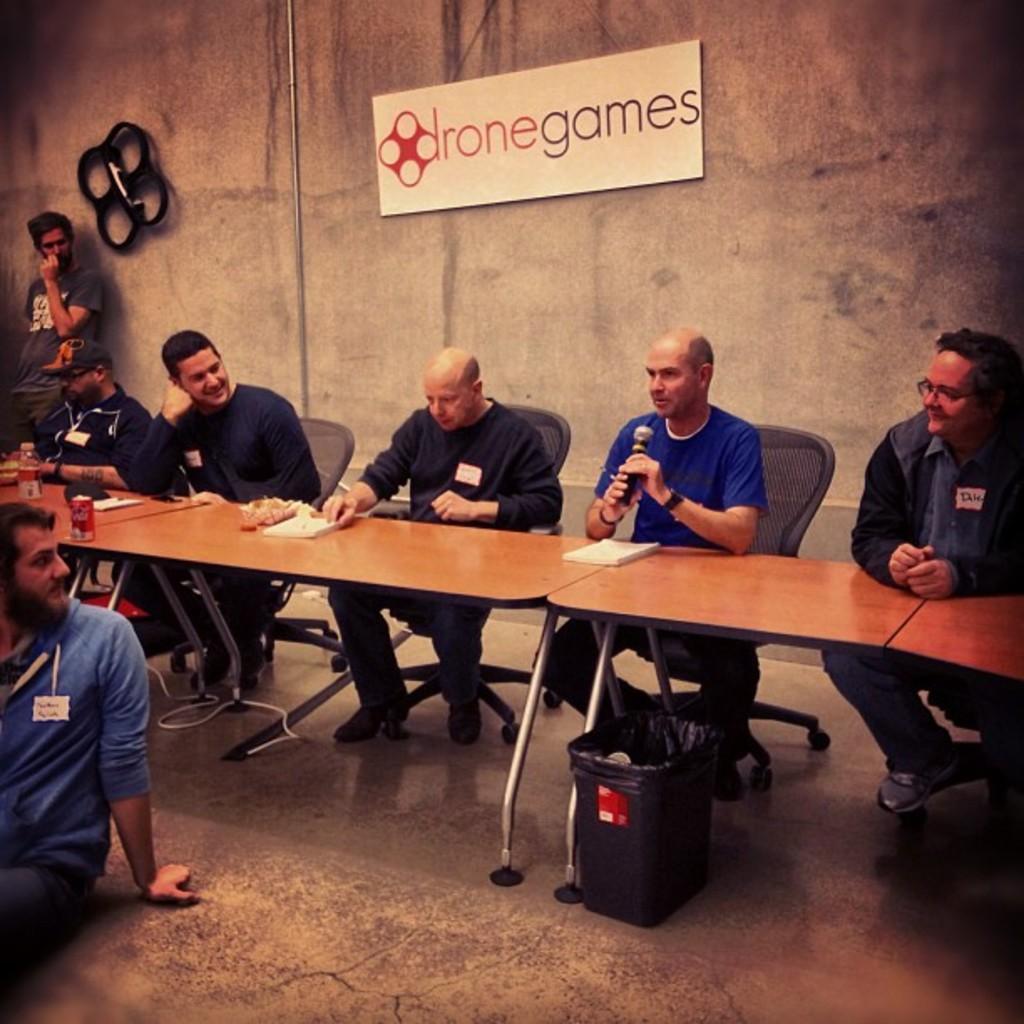In one or two sentences, can you explain what this image depicts? In this image there are some tables on which books are kept and some people sitting on the chairs looking at each other. And a man sitting on the ground looking behind him and in the background there is a wall which is in brown color and on that wall it is written as iron games. 